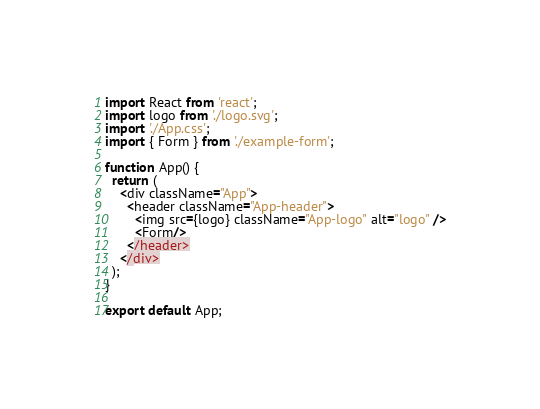<code> <loc_0><loc_0><loc_500><loc_500><_TypeScript_>import React from 'react';
import logo from './logo.svg';
import './App.css';
import { Form } from './example-form';

function App() {
  return (
    <div className="App">
      <header className="App-header">
        <img src={logo} className="App-logo" alt="logo" />
        <Form/>
      </header>
    </div>
  );
}

export default App;
</code> 